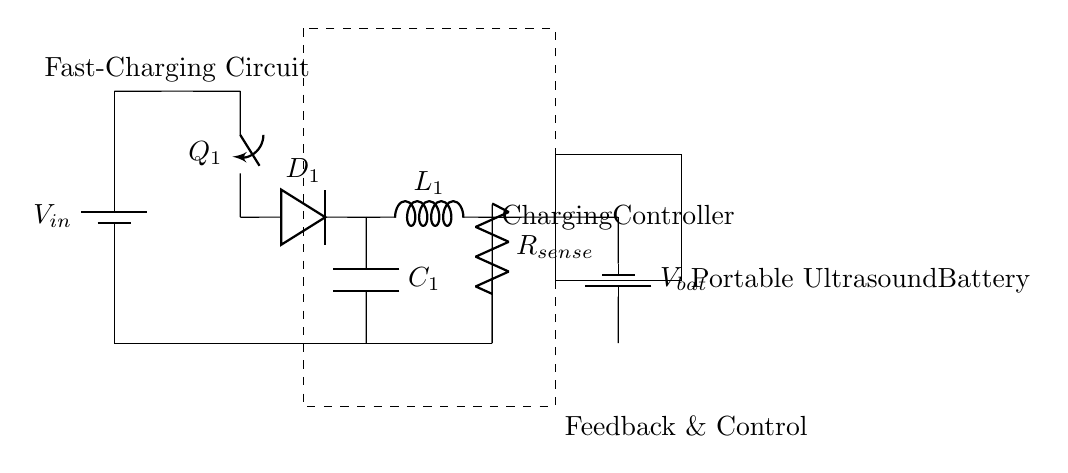What is the input voltage for the circuit? The input voltage can be found in the schematic, labeled as \(V_{in}\), which represents the voltage supplied to the circuit.
Answer: \(V_{in}\) What type of converter is used in this circuit? The circuit diagram shows a switch connected to a diode and inductor, indicating that it uses a buck converter to step down the input voltage.
Answer: Buck converter What is the purpose of the inductor in this circuit? The inductor in a buck converter is used to store energy during the switch-on phase and release it when the switch is off, helping to regulate the output voltage.
Answer: Energy storage How does the charging controller receive feedback? The feedback for the charging controller is likely derived from the current flowing through the resistor labeled \(R_{sense}\), which allows the controller to adjust the charging process based on this measurement.
Answer: Current sensing What does the rectangle labeled "Feedback & Control" represent? The labeled rectangle indicates a block that contains the feedback and control mechanisms, which monitor and adjust the charging process to ensure safe and efficient battery charging.
Answer: Control circuit What is the role of the diode in the charging circuit? The diode allows current to flow only in one direction, thereby preventing the battery from discharging back into the circuit. It ensures that energy flows into the battery during charging.
Answer: Current direction control What could happen if the switch \(Q_1\) fails to open? If switch \(Q_1\) fails to open, it would continuously allow current to flow, potentially causing overcharging of the battery, overheating, or damage, leading to failure of the battery or circuit.
Answer: Overcharging risk 